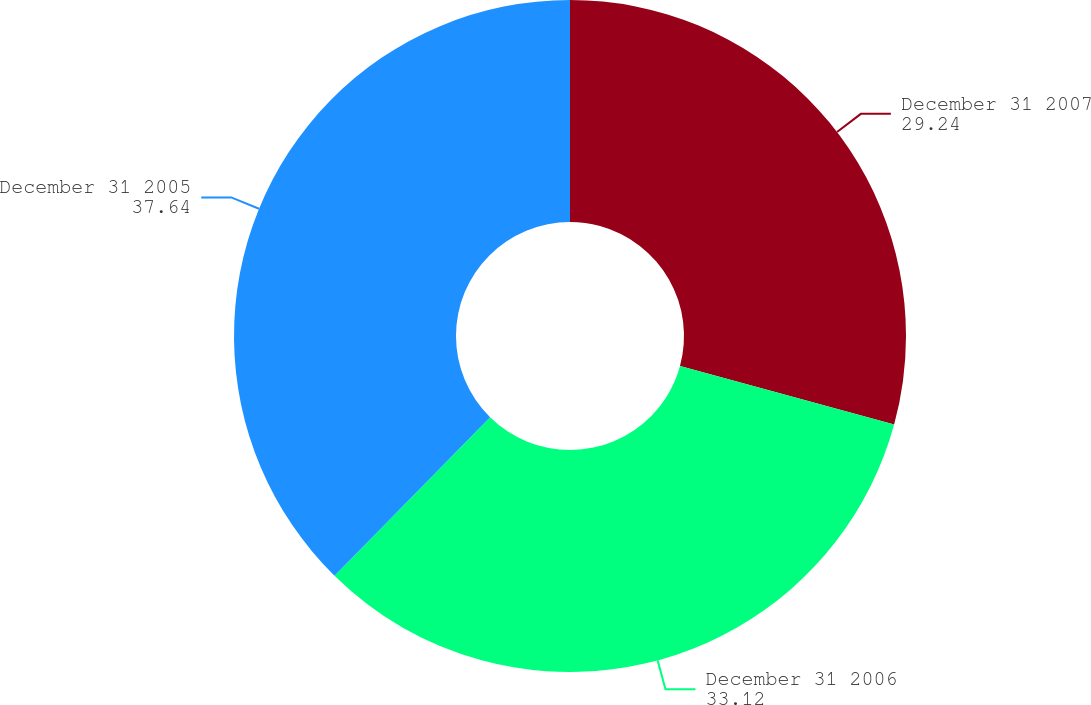Convert chart. <chart><loc_0><loc_0><loc_500><loc_500><pie_chart><fcel>December 31 2007<fcel>December 31 2006<fcel>December 31 2005<nl><fcel>29.24%<fcel>33.12%<fcel>37.64%<nl></chart> 